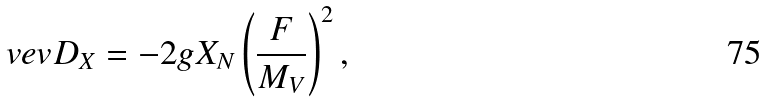<formula> <loc_0><loc_0><loc_500><loc_500>\ v e v { D _ { X } } = - 2 g X _ { N } \left ( \frac { F } { M _ { V } } \right ) ^ { 2 } ,</formula> 